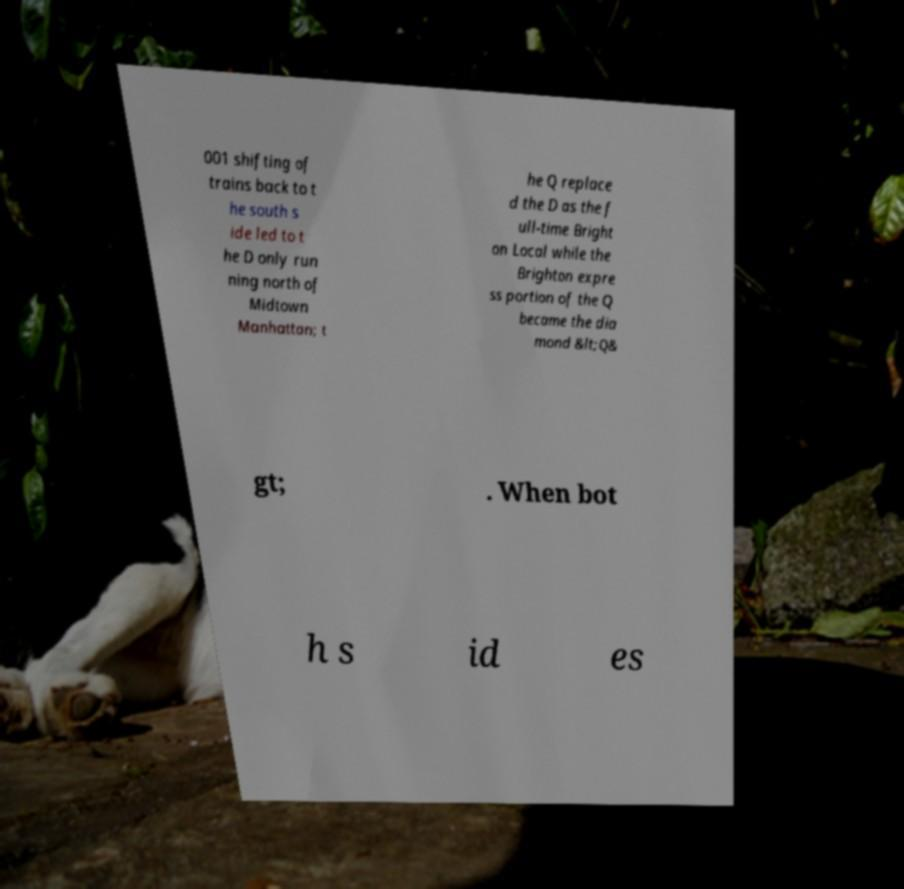I need the written content from this picture converted into text. Can you do that? 001 shifting of trains back to t he south s ide led to t he D only run ning north of Midtown Manhattan; t he Q replace d the D as the f ull-time Bright on Local while the Brighton expre ss portion of the Q became the dia mond &lt;Q& gt; . When bot h s id es 